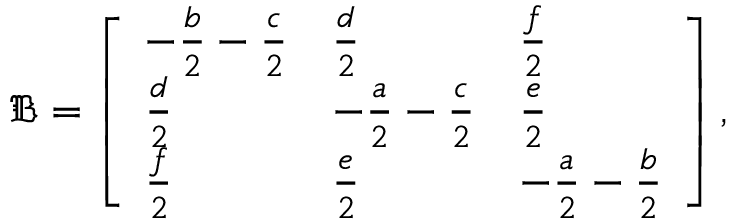<formula> <loc_0><loc_0><loc_500><loc_500>\mathfrak { B } = \left [ \begin{array} { l l l } { - \frac { b } { 2 } - \frac { c } { 2 } } & { \frac { d } { 2 } } & { \frac { f } { 2 } } \\ { \frac { d } { 2 } } & { - \frac { a } { 2 } - \frac { c } { 2 } } & { \frac { e } { 2 } } \\ { \frac { f } { 2 } } & { \frac { e } { 2 } } & { - \frac { a } { 2 } - \frac { b } { 2 } } \end{array} \right ] ,</formula> 